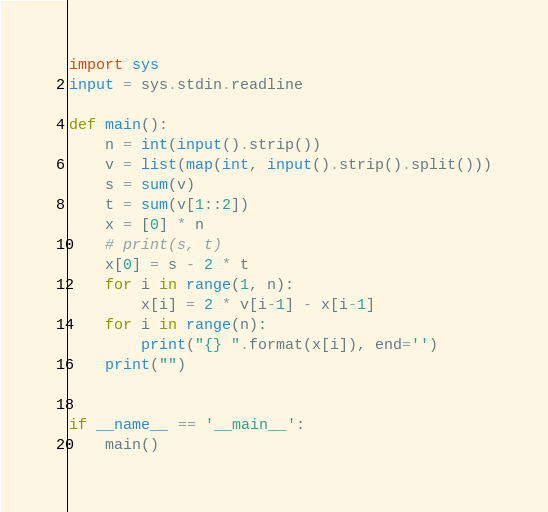Convert code to text. <code><loc_0><loc_0><loc_500><loc_500><_Python_>import sys
input = sys.stdin.readline

def main():
	n = int(input().strip())
	v = list(map(int, input().strip().split()))
	s = sum(v)
	t = sum(v[1::2])
	x = [0] * n
	# print(s, t)
	x[0] = s - 2 * t
	for i in range(1, n):
		x[i] = 2 * v[i-1] - x[i-1]
	for i in range(n):
		print("{} ".format(x[i]), end='')
	print("")


if __name__ == '__main__':
	main()
</code> 